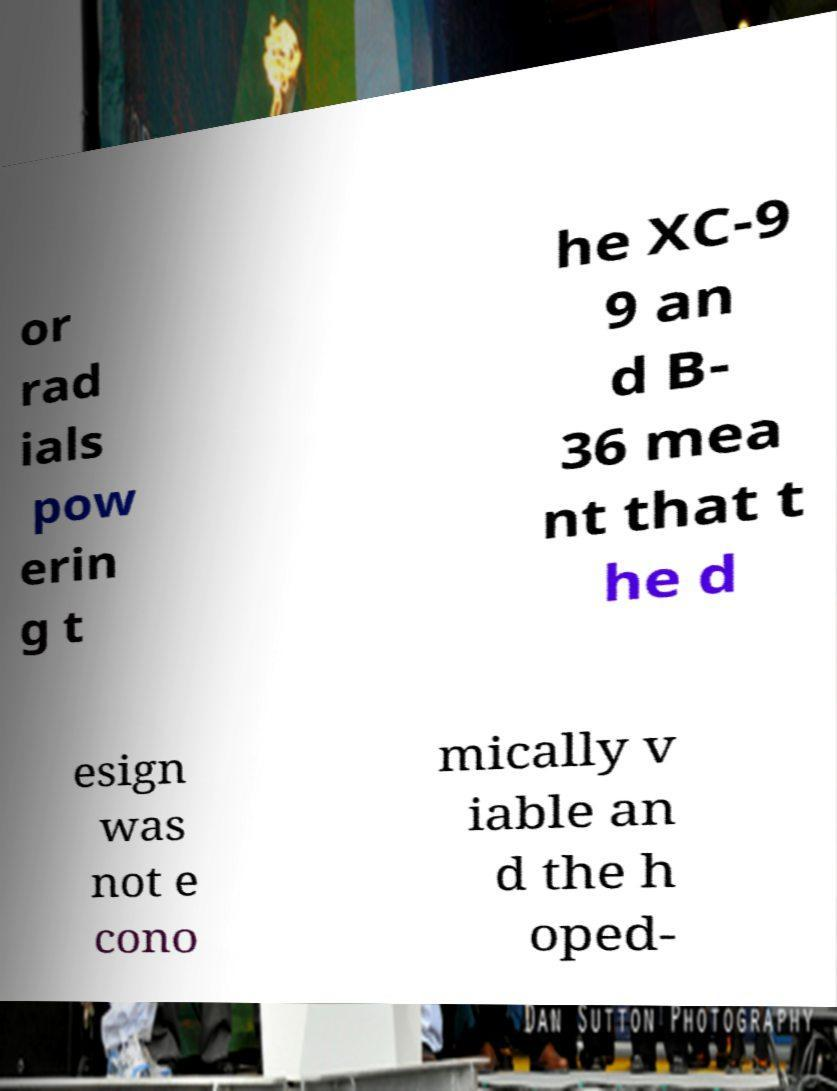Could you extract and type out the text from this image? or rad ials pow erin g t he XC-9 9 an d B- 36 mea nt that t he d esign was not e cono mically v iable an d the h oped- 